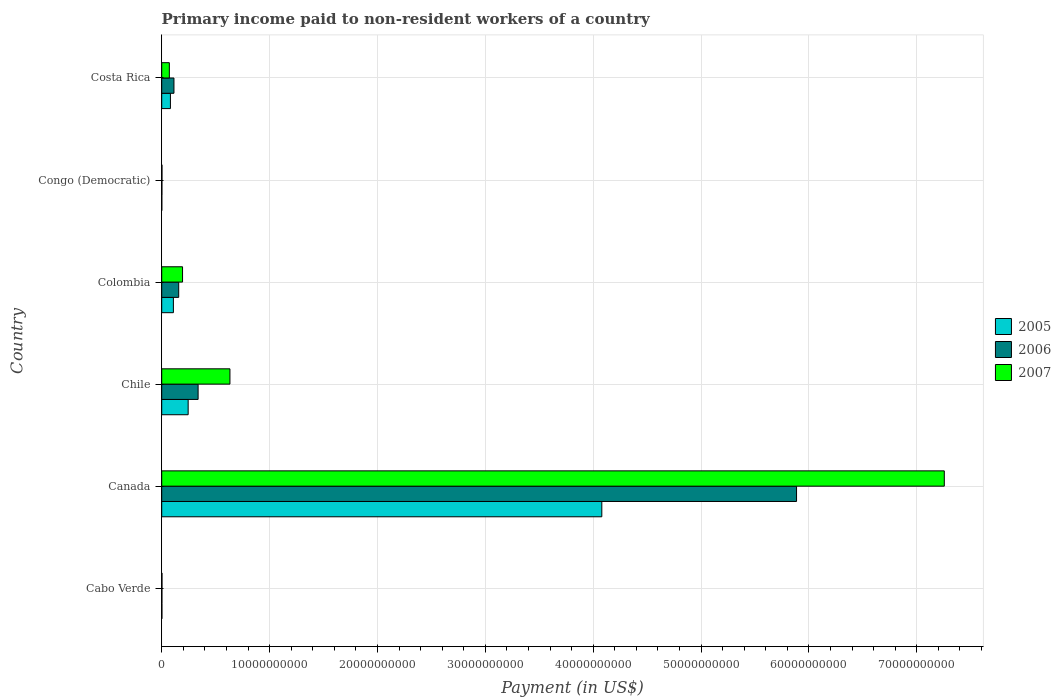How many groups of bars are there?
Ensure brevity in your answer.  6. Are the number of bars per tick equal to the number of legend labels?
Make the answer very short. Yes. Are the number of bars on each tick of the Y-axis equal?
Keep it short and to the point. Yes. In how many cases, is the number of bars for a given country not equal to the number of legend labels?
Your response must be concise. 0. What is the amount paid to workers in 2005 in Colombia?
Your answer should be compact. 1.08e+09. Across all countries, what is the maximum amount paid to workers in 2005?
Make the answer very short. 4.08e+1. Across all countries, what is the minimum amount paid to workers in 2005?
Provide a succinct answer. 9.50e+06. In which country was the amount paid to workers in 2006 minimum?
Provide a succinct answer. Congo (Democratic). What is the total amount paid to workers in 2005 in the graph?
Make the answer very short. 4.52e+1. What is the difference between the amount paid to workers in 2005 in Congo (Democratic) and that in Costa Rica?
Make the answer very short. -7.97e+08. What is the difference between the amount paid to workers in 2006 in Canada and the amount paid to workers in 2007 in Chile?
Your answer should be compact. 5.25e+1. What is the average amount paid to workers in 2006 per country?
Provide a succinct answer. 1.08e+1. What is the difference between the amount paid to workers in 2006 and amount paid to workers in 2007 in Costa Rica?
Offer a terse response. 4.27e+08. In how many countries, is the amount paid to workers in 2006 greater than 64000000000 US$?
Your answer should be very brief. 0. What is the ratio of the amount paid to workers in 2007 in Chile to that in Congo (Democratic)?
Make the answer very short. 243.27. Is the difference between the amount paid to workers in 2006 in Canada and Congo (Democratic) greater than the difference between the amount paid to workers in 2007 in Canada and Congo (Democratic)?
Keep it short and to the point. No. What is the difference between the highest and the second highest amount paid to workers in 2006?
Keep it short and to the point. 5.55e+1. What is the difference between the highest and the lowest amount paid to workers in 2007?
Your answer should be very brief. 7.25e+1. In how many countries, is the amount paid to workers in 2006 greater than the average amount paid to workers in 2006 taken over all countries?
Offer a very short reply. 1. What does the 1st bar from the top in Congo (Democratic) represents?
Your response must be concise. 2007. What does the 1st bar from the bottom in Congo (Democratic) represents?
Ensure brevity in your answer.  2005. Is it the case that in every country, the sum of the amount paid to workers in 2007 and amount paid to workers in 2005 is greater than the amount paid to workers in 2006?
Your response must be concise. Yes. How many bars are there?
Your answer should be very brief. 18. Are all the bars in the graph horizontal?
Your answer should be very brief. Yes. What is the difference between two consecutive major ticks on the X-axis?
Offer a very short reply. 1.00e+1. Are the values on the major ticks of X-axis written in scientific E-notation?
Provide a succinct answer. No. Where does the legend appear in the graph?
Offer a terse response. Center right. What is the title of the graph?
Provide a short and direct response. Primary income paid to non-resident workers of a country. What is the label or title of the X-axis?
Ensure brevity in your answer.  Payment (in US$). What is the Payment (in US$) in 2005 in Cabo Verde?
Make the answer very short. 1.92e+07. What is the Payment (in US$) in 2006 in Cabo Verde?
Provide a short and direct response. 1.91e+07. What is the Payment (in US$) in 2007 in Cabo Verde?
Provide a short and direct response. 2.67e+07. What is the Payment (in US$) of 2005 in Canada?
Provide a succinct answer. 4.08e+1. What is the Payment (in US$) of 2006 in Canada?
Keep it short and to the point. 5.89e+1. What is the Payment (in US$) of 2007 in Canada?
Ensure brevity in your answer.  7.26e+1. What is the Payment (in US$) in 2005 in Chile?
Make the answer very short. 2.45e+09. What is the Payment (in US$) in 2006 in Chile?
Provide a short and direct response. 3.37e+09. What is the Payment (in US$) of 2007 in Chile?
Ensure brevity in your answer.  6.32e+09. What is the Payment (in US$) of 2005 in Colombia?
Offer a very short reply. 1.08e+09. What is the Payment (in US$) in 2006 in Colombia?
Your answer should be very brief. 1.58e+09. What is the Payment (in US$) of 2007 in Colombia?
Offer a very short reply. 1.93e+09. What is the Payment (in US$) of 2005 in Congo (Democratic)?
Make the answer very short. 9.50e+06. What is the Payment (in US$) of 2006 in Congo (Democratic)?
Your answer should be very brief. 1.77e+07. What is the Payment (in US$) of 2007 in Congo (Democratic)?
Your answer should be very brief. 2.60e+07. What is the Payment (in US$) of 2005 in Costa Rica?
Make the answer very short. 8.07e+08. What is the Payment (in US$) in 2006 in Costa Rica?
Make the answer very short. 1.14e+09. What is the Payment (in US$) in 2007 in Costa Rica?
Keep it short and to the point. 7.08e+08. Across all countries, what is the maximum Payment (in US$) of 2005?
Offer a very short reply. 4.08e+1. Across all countries, what is the maximum Payment (in US$) in 2006?
Provide a short and direct response. 5.89e+1. Across all countries, what is the maximum Payment (in US$) of 2007?
Your response must be concise. 7.26e+1. Across all countries, what is the minimum Payment (in US$) in 2005?
Offer a terse response. 9.50e+06. Across all countries, what is the minimum Payment (in US$) of 2006?
Give a very brief answer. 1.77e+07. Across all countries, what is the minimum Payment (in US$) of 2007?
Ensure brevity in your answer.  2.60e+07. What is the total Payment (in US$) in 2005 in the graph?
Your answer should be compact. 4.52e+1. What is the total Payment (in US$) in 2006 in the graph?
Ensure brevity in your answer.  6.50e+1. What is the total Payment (in US$) of 2007 in the graph?
Keep it short and to the point. 8.16e+1. What is the difference between the Payment (in US$) of 2005 in Cabo Verde and that in Canada?
Give a very brief answer. -4.08e+1. What is the difference between the Payment (in US$) in 2006 in Cabo Verde and that in Canada?
Your response must be concise. -5.88e+1. What is the difference between the Payment (in US$) in 2007 in Cabo Verde and that in Canada?
Your answer should be compact. -7.25e+1. What is the difference between the Payment (in US$) of 2005 in Cabo Verde and that in Chile?
Ensure brevity in your answer.  -2.43e+09. What is the difference between the Payment (in US$) of 2006 in Cabo Verde and that in Chile?
Your answer should be very brief. -3.36e+09. What is the difference between the Payment (in US$) of 2007 in Cabo Verde and that in Chile?
Give a very brief answer. -6.30e+09. What is the difference between the Payment (in US$) of 2005 in Cabo Verde and that in Colombia?
Make the answer very short. -1.06e+09. What is the difference between the Payment (in US$) of 2006 in Cabo Verde and that in Colombia?
Keep it short and to the point. -1.56e+09. What is the difference between the Payment (in US$) of 2007 in Cabo Verde and that in Colombia?
Provide a short and direct response. -1.90e+09. What is the difference between the Payment (in US$) in 2005 in Cabo Verde and that in Congo (Democratic)?
Keep it short and to the point. 9.73e+06. What is the difference between the Payment (in US$) of 2006 in Cabo Verde and that in Congo (Democratic)?
Your response must be concise. 1.37e+06. What is the difference between the Payment (in US$) of 2007 in Cabo Verde and that in Congo (Democratic)?
Ensure brevity in your answer.  7.30e+05. What is the difference between the Payment (in US$) of 2005 in Cabo Verde and that in Costa Rica?
Your response must be concise. -7.88e+08. What is the difference between the Payment (in US$) in 2006 in Cabo Verde and that in Costa Rica?
Offer a very short reply. -1.12e+09. What is the difference between the Payment (in US$) of 2007 in Cabo Verde and that in Costa Rica?
Ensure brevity in your answer.  -6.81e+08. What is the difference between the Payment (in US$) of 2005 in Canada and that in Chile?
Provide a succinct answer. 3.83e+1. What is the difference between the Payment (in US$) of 2006 in Canada and that in Chile?
Offer a very short reply. 5.55e+1. What is the difference between the Payment (in US$) of 2007 in Canada and that in Chile?
Make the answer very short. 6.62e+1. What is the difference between the Payment (in US$) of 2005 in Canada and that in Colombia?
Make the answer very short. 3.97e+1. What is the difference between the Payment (in US$) of 2006 in Canada and that in Colombia?
Give a very brief answer. 5.73e+1. What is the difference between the Payment (in US$) in 2007 in Canada and that in Colombia?
Ensure brevity in your answer.  7.06e+1. What is the difference between the Payment (in US$) of 2005 in Canada and that in Congo (Democratic)?
Offer a terse response. 4.08e+1. What is the difference between the Payment (in US$) in 2006 in Canada and that in Congo (Democratic)?
Make the answer very short. 5.88e+1. What is the difference between the Payment (in US$) of 2007 in Canada and that in Congo (Democratic)?
Make the answer very short. 7.25e+1. What is the difference between the Payment (in US$) in 2005 in Canada and that in Costa Rica?
Keep it short and to the point. 4.00e+1. What is the difference between the Payment (in US$) of 2006 in Canada and that in Costa Rica?
Offer a very short reply. 5.77e+1. What is the difference between the Payment (in US$) of 2007 in Canada and that in Costa Rica?
Make the answer very short. 7.18e+1. What is the difference between the Payment (in US$) in 2005 in Chile and that in Colombia?
Your response must be concise. 1.37e+09. What is the difference between the Payment (in US$) in 2006 in Chile and that in Colombia?
Make the answer very short. 1.80e+09. What is the difference between the Payment (in US$) of 2007 in Chile and that in Colombia?
Make the answer very short. 4.39e+09. What is the difference between the Payment (in US$) in 2005 in Chile and that in Congo (Democratic)?
Your answer should be compact. 2.44e+09. What is the difference between the Payment (in US$) of 2006 in Chile and that in Congo (Democratic)?
Ensure brevity in your answer.  3.36e+09. What is the difference between the Payment (in US$) in 2007 in Chile and that in Congo (Democratic)?
Keep it short and to the point. 6.30e+09. What is the difference between the Payment (in US$) in 2005 in Chile and that in Costa Rica?
Keep it short and to the point. 1.65e+09. What is the difference between the Payment (in US$) in 2006 in Chile and that in Costa Rica?
Offer a terse response. 2.24e+09. What is the difference between the Payment (in US$) in 2007 in Chile and that in Costa Rica?
Provide a succinct answer. 5.62e+09. What is the difference between the Payment (in US$) of 2005 in Colombia and that in Congo (Democratic)?
Your answer should be very brief. 1.07e+09. What is the difference between the Payment (in US$) of 2006 in Colombia and that in Congo (Democratic)?
Provide a short and direct response. 1.56e+09. What is the difference between the Payment (in US$) of 2007 in Colombia and that in Congo (Democratic)?
Provide a short and direct response. 1.91e+09. What is the difference between the Payment (in US$) in 2005 in Colombia and that in Costa Rica?
Keep it short and to the point. 2.77e+08. What is the difference between the Payment (in US$) of 2006 in Colombia and that in Costa Rica?
Make the answer very short. 4.40e+08. What is the difference between the Payment (in US$) of 2007 in Colombia and that in Costa Rica?
Give a very brief answer. 1.22e+09. What is the difference between the Payment (in US$) of 2005 in Congo (Democratic) and that in Costa Rica?
Offer a terse response. -7.97e+08. What is the difference between the Payment (in US$) in 2006 in Congo (Democratic) and that in Costa Rica?
Offer a very short reply. -1.12e+09. What is the difference between the Payment (in US$) of 2007 in Congo (Democratic) and that in Costa Rica?
Offer a terse response. -6.82e+08. What is the difference between the Payment (in US$) of 2005 in Cabo Verde and the Payment (in US$) of 2006 in Canada?
Give a very brief answer. -5.88e+1. What is the difference between the Payment (in US$) of 2005 in Cabo Verde and the Payment (in US$) of 2007 in Canada?
Provide a short and direct response. -7.25e+1. What is the difference between the Payment (in US$) of 2006 in Cabo Verde and the Payment (in US$) of 2007 in Canada?
Offer a terse response. -7.25e+1. What is the difference between the Payment (in US$) of 2005 in Cabo Verde and the Payment (in US$) of 2006 in Chile?
Keep it short and to the point. -3.36e+09. What is the difference between the Payment (in US$) in 2005 in Cabo Verde and the Payment (in US$) in 2007 in Chile?
Keep it short and to the point. -6.31e+09. What is the difference between the Payment (in US$) in 2006 in Cabo Verde and the Payment (in US$) in 2007 in Chile?
Give a very brief answer. -6.31e+09. What is the difference between the Payment (in US$) in 2005 in Cabo Verde and the Payment (in US$) in 2006 in Colombia?
Your answer should be very brief. -1.56e+09. What is the difference between the Payment (in US$) in 2005 in Cabo Verde and the Payment (in US$) in 2007 in Colombia?
Offer a terse response. -1.91e+09. What is the difference between the Payment (in US$) in 2006 in Cabo Verde and the Payment (in US$) in 2007 in Colombia?
Provide a short and direct response. -1.91e+09. What is the difference between the Payment (in US$) in 2005 in Cabo Verde and the Payment (in US$) in 2006 in Congo (Democratic)?
Offer a very short reply. 1.53e+06. What is the difference between the Payment (in US$) of 2005 in Cabo Verde and the Payment (in US$) of 2007 in Congo (Democratic)?
Offer a terse response. -6.77e+06. What is the difference between the Payment (in US$) in 2006 in Cabo Verde and the Payment (in US$) in 2007 in Congo (Democratic)?
Your answer should be compact. -6.93e+06. What is the difference between the Payment (in US$) of 2005 in Cabo Verde and the Payment (in US$) of 2006 in Costa Rica?
Offer a very short reply. -1.12e+09. What is the difference between the Payment (in US$) in 2005 in Cabo Verde and the Payment (in US$) in 2007 in Costa Rica?
Your answer should be compact. -6.88e+08. What is the difference between the Payment (in US$) in 2006 in Cabo Verde and the Payment (in US$) in 2007 in Costa Rica?
Provide a succinct answer. -6.89e+08. What is the difference between the Payment (in US$) of 2005 in Canada and the Payment (in US$) of 2006 in Chile?
Make the answer very short. 3.74e+1. What is the difference between the Payment (in US$) of 2005 in Canada and the Payment (in US$) of 2007 in Chile?
Provide a succinct answer. 3.45e+1. What is the difference between the Payment (in US$) of 2006 in Canada and the Payment (in US$) of 2007 in Chile?
Offer a terse response. 5.25e+1. What is the difference between the Payment (in US$) in 2005 in Canada and the Payment (in US$) in 2006 in Colombia?
Offer a terse response. 3.92e+1. What is the difference between the Payment (in US$) in 2005 in Canada and the Payment (in US$) in 2007 in Colombia?
Make the answer very short. 3.89e+1. What is the difference between the Payment (in US$) in 2006 in Canada and the Payment (in US$) in 2007 in Colombia?
Your answer should be compact. 5.69e+1. What is the difference between the Payment (in US$) of 2005 in Canada and the Payment (in US$) of 2006 in Congo (Democratic)?
Keep it short and to the point. 4.08e+1. What is the difference between the Payment (in US$) in 2005 in Canada and the Payment (in US$) in 2007 in Congo (Democratic)?
Your answer should be very brief. 4.08e+1. What is the difference between the Payment (in US$) in 2006 in Canada and the Payment (in US$) in 2007 in Congo (Democratic)?
Offer a terse response. 5.88e+1. What is the difference between the Payment (in US$) of 2005 in Canada and the Payment (in US$) of 2006 in Costa Rica?
Your answer should be compact. 3.97e+1. What is the difference between the Payment (in US$) in 2005 in Canada and the Payment (in US$) in 2007 in Costa Rica?
Provide a succinct answer. 4.01e+1. What is the difference between the Payment (in US$) in 2006 in Canada and the Payment (in US$) in 2007 in Costa Rica?
Offer a terse response. 5.81e+1. What is the difference between the Payment (in US$) of 2005 in Chile and the Payment (in US$) of 2006 in Colombia?
Your answer should be very brief. 8.77e+08. What is the difference between the Payment (in US$) in 2005 in Chile and the Payment (in US$) in 2007 in Colombia?
Provide a short and direct response. 5.21e+08. What is the difference between the Payment (in US$) in 2006 in Chile and the Payment (in US$) in 2007 in Colombia?
Your answer should be very brief. 1.44e+09. What is the difference between the Payment (in US$) in 2005 in Chile and the Payment (in US$) in 2006 in Congo (Democratic)?
Keep it short and to the point. 2.43e+09. What is the difference between the Payment (in US$) of 2005 in Chile and the Payment (in US$) of 2007 in Congo (Democratic)?
Keep it short and to the point. 2.43e+09. What is the difference between the Payment (in US$) in 2006 in Chile and the Payment (in US$) in 2007 in Congo (Democratic)?
Your answer should be compact. 3.35e+09. What is the difference between the Payment (in US$) of 2005 in Chile and the Payment (in US$) of 2006 in Costa Rica?
Provide a succinct answer. 1.32e+09. What is the difference between the Payment (in US$) of 2005 in Chile and the Payment (in US$) of 2007 in Costa Rica?
Provide a succinct answer. 1.74e+09. What is the difference between the Payment (in US$) in 2006 in Chile and the Payment (in US$) in 2007 in Costa Rica?
Your answer should be very brief. 2.67e+09. What is the difference between the Payment (in US$) of 2005 in Colombia and the Payment (in US$) of 2006 in Congo (Democratic)?
Provide a succinct answer. 1.07e+09. What is the difference between the Payment (in US$) of 2005 in Colombia and the Payment (in US$) of 2007 in Congo (Democratic)?
Your answer should be very brief. 1.06e+09. What is the difference between the Payment (in US$) of 2006 in Colombia and the Payment (in US$) of 2007 in Congo (Democratic)?
Ensure brevity in your answer.  1.55e+09. What is the difference between the Payment (in US$) of 2005 in Colombia and the Payment (in US$) of 2006 in Costa Rica?
Offer a terse response. -5.16e+07. What is the difference between the Payment (in US$) of 2005 in Colombia and the Payment (in US$) of 2007 in Costa Rica?
Your answer should be very brief. 3.76e+08. What is the difference between the Payment (in US$) of 2006 in Colombia and the Payment (in US$) of 2007 in Costa Rica?
Your answer should be very brief. 8.67e+08. What is the difference between the Payment (in US$) in 2005 in Congo (Democratic) and the Payment (in US$) in 2006 in Costa Rica?
Provide a succinct answer. -1.13e+09. What is the difference between the Payment (in US$) in 2005 in Congo (Democratic) and the Payment (in US$) in 2007 in Costa Rica?
Provide a succinct answer. -6.98e+08. What is the difference between the Payment (in US$) in 2006 in Congo (Democratic) and the Payment (in US$) in 2007 in Costa Rica?
Give a very brief answer. -6.90e+08. What is the average Payment (in US$) of 2005 per country?
Provide a succinct answer. 7.53e+09. What is the average Payment (in US$) of 2006 per country?
Your answer should be compact. 1.08e+1. What is the average Payment (in US$) in 2007 per country?
Offer a terse response. 1.36e+1. What is the difference between the Payment (in US$) of 2005 and Payment (in US$) of 2006 in Cabo Verde?
Provide a short and direct response. 1.54e+05. What is the difference between the Payment (in US$) of 2005 and Payment (in US$) of 2007 in Cabo Verde?
Your response must be concise. -7.50e+06. What is the difference between the Payment (in US$) of 2006 and Payment (in US$) of 2007 in Cabo Verde?
Provide a short and direct response. -7.66e+06. What is the difference between the Payment (in US$) of 2005 and Payment (in US$) of 2006 in Canada?
Your answer should be very brief. -1.81e+1. What is the difference between the Payment (in US$) of 2005 and Payment (in US$) of 2007 in Canada?
Make the answer very short. -3.18e+1. What is the difference between the Payment (in US$) of 2006 and Payment (in US$) of 2007 in Canada?
Ensure brevity in your answer.  -1.37e+1. What is the difference between the Payment (in US$) in 2005 and Payment (in US$) in 2006 in Chile?
Your response must be concise. -9.22e+08. What is the difference between the Payment (in US$) in 2005 and Payment (in US$) in 2007 in Chile?
Your response must be concise. -3.87e+09. What is the difference between the Payment (in US$) of 2006 and Payment (in US$) of 2007 in Chile?
Provide a short and direct response. -2.95e+09. What is the difference between the Payment (in US$) of 2005 and Payment (in US$) of 2006 in Colombia?
Your response must be concise. -4.92e+08. What is the difference between the Payment (in US$) of 2005 and Payment (in US$) of 2007 in Colombia?
Provide a short and direct response. -8.48e+08. What is the difference between the Payment (in US$) in 2006 and Payment (in US$) in 2007 in Colombia?
Offer a terse response. -3.56e+08. What is the difference between the Payment (in US$) of 2005 and Payment (in US$) of 2006 in Congo (Democratic)?
Offer a very short reply. -8.20e+06. What is the difference between the Payment (in US$) in 2005 and Payment (in US$) in 2007 in Congo (Democratic)?
Offer a terse response. -1.65e+07. What is the difference between the Payment (in US$) in 2006 and Payment (in US$) in 2007 in Congo (Democratic)?
Provide a short and direct response. -8.30e+06. What is the difference between the Payment (in US$) in 2005 and Payment (in US$) in 2006 in Costa Rica?
Provide a succinct answer. -3.28e+08. What is the difference between the Payment (in US$) of 2005 and Payment (in US$) of 2007 in Costa Rica?
Give a very brief answer. 9.92e+07. What is the difference between the Payment (in US$) of 2006 and Payment (in US$) of 2007 in Costa Rica?
Your response must be concise. 4.27e+08. What is the ratio of the Payment (in US$) in 2007 in Cabo Verde to that in Canada?
Make the answer very short. 0. What is the ratio of the Payment (in US$) in 2005 in Cabo Verde to that in Chile?
Keep it short and to the point. 0.01. What is the ratio of the Payment (in US$) in 2006 in Cabo Verde to that in Chile?
Offer a terse response. 0.01. What is the ratio of the Payment (in US$) in 2007 in Cabo Verde to that in Chile?
Make the answer very short. 0. What is the ratio of the Payment (in US$) of 2005 in Cabo Verde to that in Colombia?
Your answer should be compact. 0.02. What is the ratio of the Payment (in US$) in 2006 in Cabo Verde to that in Colombia?
Make the answer very short. 0.01. What is the ratio of the Payment (in US$) in 2007 in Cabo Verde to that in Colombia?
Keep it short and to the point. 0.01. What is the ratio of the Payment (in US$) in 2005 in Cabo Verde to that in Congo (Democratic)?
Give a very brief answer. 2.02. What is the ratio of the Payment (in US$) in 2006 in Cabo Verde to that in Congo (Democratic)?
Your answer should be very brief. 1.08. What is the ratio of the Payment (in US$) of 2007 in Cabo Verde to that in Congo (Democratic)?
Your response must be concise. 1.03. What is the ratio of the Payment (in US$) in 2005 in Cabo Verde to that in Costa Rica?
Provide a succinct answer. 0.02. What is the ratio of the Payment (in US$) of 2006 in Cabo Verde to that in Costa Rica?
Offer a very short reply. 0.02. What is the ratio of the Payment (in US$) of 2007 in Cabo Verde to that in Costa Rica?
Give a very brief answer. 0.04. What is the ratio of the Payment (in US$) of 2005 in Canada to that in Chile?
Offer a terse response. 16.64. What is the ratio of the Payment (in US$) in 2006 in Canada to that in Chile?
Your answer should be compact. 17.44. What is the ratio of the Payment (in US$) in 2007 in Canada to that in Chile?
Offer a very short reply. 11.47. What is the ratio of the Payment (in US$) in 2005 in Canada to that in Colombia?
Your response must be concise. 37.66. What is the ratio of the Payment (in US$) of 2006 in Canada to that in Colombia?
Your answer should be compact. 37.37. What is the ratio of the Payment (in US$) in 2007 in Canada to that in Colombia?
Your response must be concise. 37.57. What is the ratio of the Payment (in US$) of 2005 in Canada to that in Congo (Democratic)?
Ensure brevity in your answer.  4294.87. What is the ratio of the Payment (in US$) in 2006 in Canada to that in Congo (Democratic)?
Provide a short and direct response. 3325.15. What is the ratio of the Payment (in US$) of 2007 in Canada to that in Congo (Democratic)?
Ensure brevity in your answer.  2790.5. What is the ratio of the Payment (in US$) in 2005 in Canada to that in Costa Rica?
Give a very brief answer. 50.57. What is the ratio of the Payment (in US$) of 2006 in Canada to that in Costa Rica?
Your answer should be compact. 51.85. What is the ratio of the Payment (in US$) of 2007 in Canada to that in Costa Rica?
Your answer should be very brief. 102.53. What is the ratio of the Payment (in US$) in 2005 in Chile to that in Colombia?
Offer a terse response. 2.26. What is the ratio of the Payment (in US$) of 2006 in Chile to that in Colombia?
Ensure brevity in your answer.  2.14. What is the ratio of the Payment (in US$) in 2007 in Chile to that in Colombia?
Give a very brief answer. 3.27. What is the ratio of the Payment (in US$) of 2005 in Chile to that in Congo (Democratic)?
Keep it short and to the point. 258.12. What is the ratio of the Payment (in US$) in 2006 in Chile to that in Congo (Democratic)?
Your answer should be very brief. 190.64. What is the ratio of the Payment (in US$) of 2007 in Chile to that in Congo (Democratic)?
Your answer should be compact. 243.27. What is the ratio of the Payment (in US$) of 2005 in Chile to that in Costa Rica?
Ensure brevity in your answer.  3.04. What is the ratio of the Payment (in US$) in 2006 in Chile to that in Costa Rica?
Provide a short and direct response. 2.97. What is the ratio of the Payment (in US$) in 2007 in Chile to that in Costa Rica?
Ensure brevity in your answer.  8.94. What is the ratio of the Payment (in US$) of 2005 in Colombia to that in Congo (Democratic)?
Ensure brevity in your answer.  114.05. What is the ratio of the Payment (in US$) of 2006 in Colombia to that in Congo (Democratic)?
Your response must be concise. 88.99. What is the ratio of the Payment (in US$) in 2007 in Colombia to that in Congo (Democratic)?
Ensure brevity in your answer.  74.28. What is the ratio of the Payment (in US$) in 2005 in Colombia to that in Costa Rica?
Provide a short and direct response. 1.34. What is the ratio of the Payment (in US$) of 2006 in Colombia to that in Costa Rica?
Keep it short and to the point. 1.39. What is the ratio of the Payment (in US$) in 2007 in Colombia to that in Costa Rica?
Provide a succinct answer. 2.73. What is the ratio of the Payment (in US$) of 2005 in Congo (Democratic) to that in Costa Rica?
Provide a succinct answer. 0.01. What is the ratio of the Payment (in US$) in 2006 in Congo (Democratic) to that in Costa Rica?
Provide a succinct answer. 0.02. What is the ratio of the Payment (in US$) of 2007 in Congo (Democratic) to that in Costa Rica?
Provide a short and direct response. 0.04. What is the difference between the highest and the second highest Payment (in US$) in 2005?
Give a very brief answer. 3.83e+1. What is the difference between the highest and the second highest Payment (in US$) of 2006?
Your answer should be compact. 5.55e+1. What is the difference between the highest and the second highest Payment (in US$) in 2007?
Your answer should be very brief. 6.62e+1. What is the difference between the highest and the lowest Payment (in US$) in 2005?
Your response must be concise. 4.08e+1. What is the difference between the highest and the lowest Payment (in US$) of 2006?
Your answer should be very brief. 5.88e+1. What is the difference between the highest and the lowest Payment (in US$) in 2007?
Make the answer very short. 7.25e+1. 